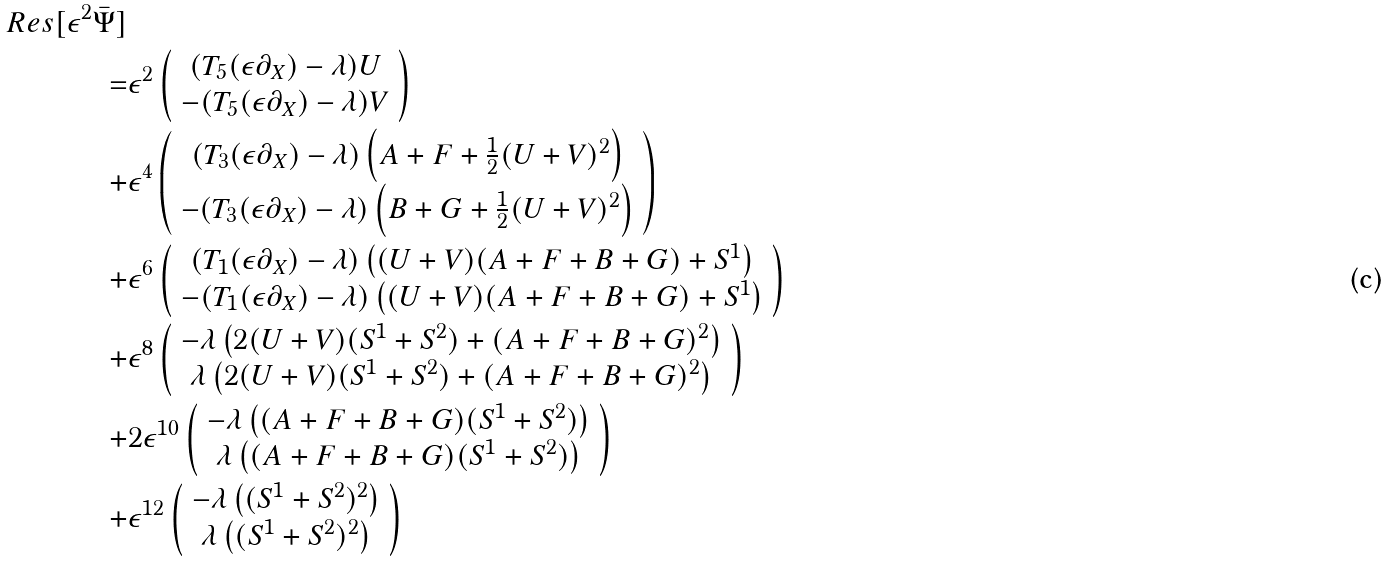<formula> <loc_0><loc_0><loc_500><loc_500>R e s [ \epsilon ^ { 2 } \bar { \Psi } ] \\ = & \epsilon ^ { 2 } \left ( \begin{array} { c } ( T _ { 5 } ( \epsilon \partial _ { X } ) - \lambda ) U \\ - ( T _ { 5 } ( \epsilon \partial _ { X } ) - \lambda ) V \end{array} \right ) \\ + & \epsilon ^ { 4 } \left ( \begin{array} { c } ( T _ { 3 } ( \epsilon \partial _ { X } ) - \lambda ) \left ( A + F + \frac { 1 } { 2 } ( U + V ) ^ { 2 } \right ) \\ - ( T _ { 3 } ( \epsilon \partial _ { X } ) - \lambda ) \left ( B + G + \frac { 1 } { 2 } ( U + V ) ^ { 2 } \right ) \end{array} \right ) \\ + & \epsilon ^ { 6 } \left ( \begin{array} { c } ( T _ { 1 } ( \epsilon \partial _ { X } ) - \lambda ) \left ( ( U + V ) ( A + F + B + G ) + S ^ { 1 } \right ) \\ - ( T _ { 1 } ( \epsilon \partial _ { X } ) - \lambda ) \left ( ( U + V ) ( A + F + B + G ) + S ^ { 1 } \right ) \end{array} \right ) \\ + & \epsilon ^ { 8 } \left ( \begin{array} { c } - \lambda \left ( 2 ( U + V ) ( S ^ { 1 } + S ^ { 2 } ) + ( A + F + B + G ) ^ { 2 } \right ) \\ \lambda \left ( 2 ( U + V ) ( S ^ { 1 } + S ^ { 2 } ) + ( A + F + B + G ) ^ { 2 } \right ) \end{array} \right ) \\ + & 2 \epsilon ^ { 1 0 } \left ( \begin{array} { c } - \lambda \left ( ( A + F + B + G ) ( S ^ { 1 } + S ^ { 2 } ) \right ) \\ \lambda \left ( ( A + F + B + G ) ( S ^ { 1 } + S ^ { 2 } ) \right ) \end{array} \right ) \\ + & \epsilon ^ { 1 2 } \left ( \begin{array} { c } - \lambda \left ( ( S ^ { 1 } + S ^ { 2 } ) ^ { 2 } \right ) \\ \lambda \left ( ( S ^ { 1 } + S ^ { 2 } ) ^ { 2 } \right ) \end{array} \right )</formula> 